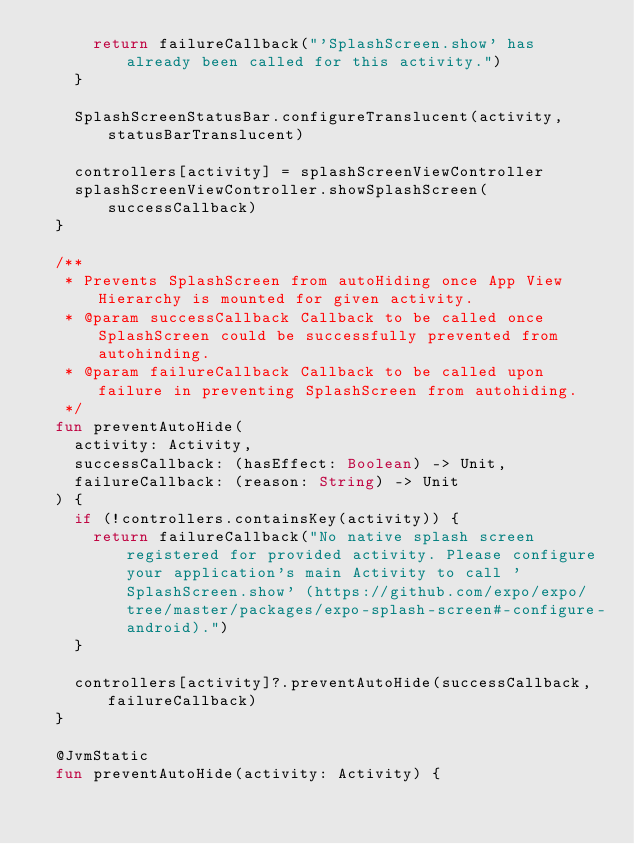<code> <loc_0><loc_0><loc_500><loc_500><_Kotlin_>      return failureCallback("'SplashScreen.show' has already been called for this activity.")
    }

    SplashScreenStatusBar.configureTranslucent(activity, statusBarTranslucent)

    controllers[activity] = splashScreenViewController
    splashScreenViewController.showSplashScreen(successCallback)
  }

  /**
   * Prevents SplashScreen from autoHiding once App View Hierarchy is mounted for given activity.
   * @param successCallback Callback to be called once SplashScreen could be successfully prevented from autohinding.
   * @param failureCallback Callback to be called upon failure in preventing SplashScreen from autohiding.
   */
  fun preventAutoHide(
    activity: Activity,
    successCallback: (hasEffect: Boolean) -> Unit,
    failureCallback: (reason: String) -> Unit
  ) {
    if (!controllers.containsKey(activity)) {
      return failureCallback("No native splash screen registered for provided activity. Please configure your application's main Activity to call 'SplashScreen.show' (https://github.com/expo/expo/tree/master/packages/expo-splash-screen#-configure-android).")
    }

    controllers[activity]?.preventAutoHide(successCallback, failureCallback)
  }

  @JvmStatic
  fun preventAutoHide(activity: Activity) {</code> 